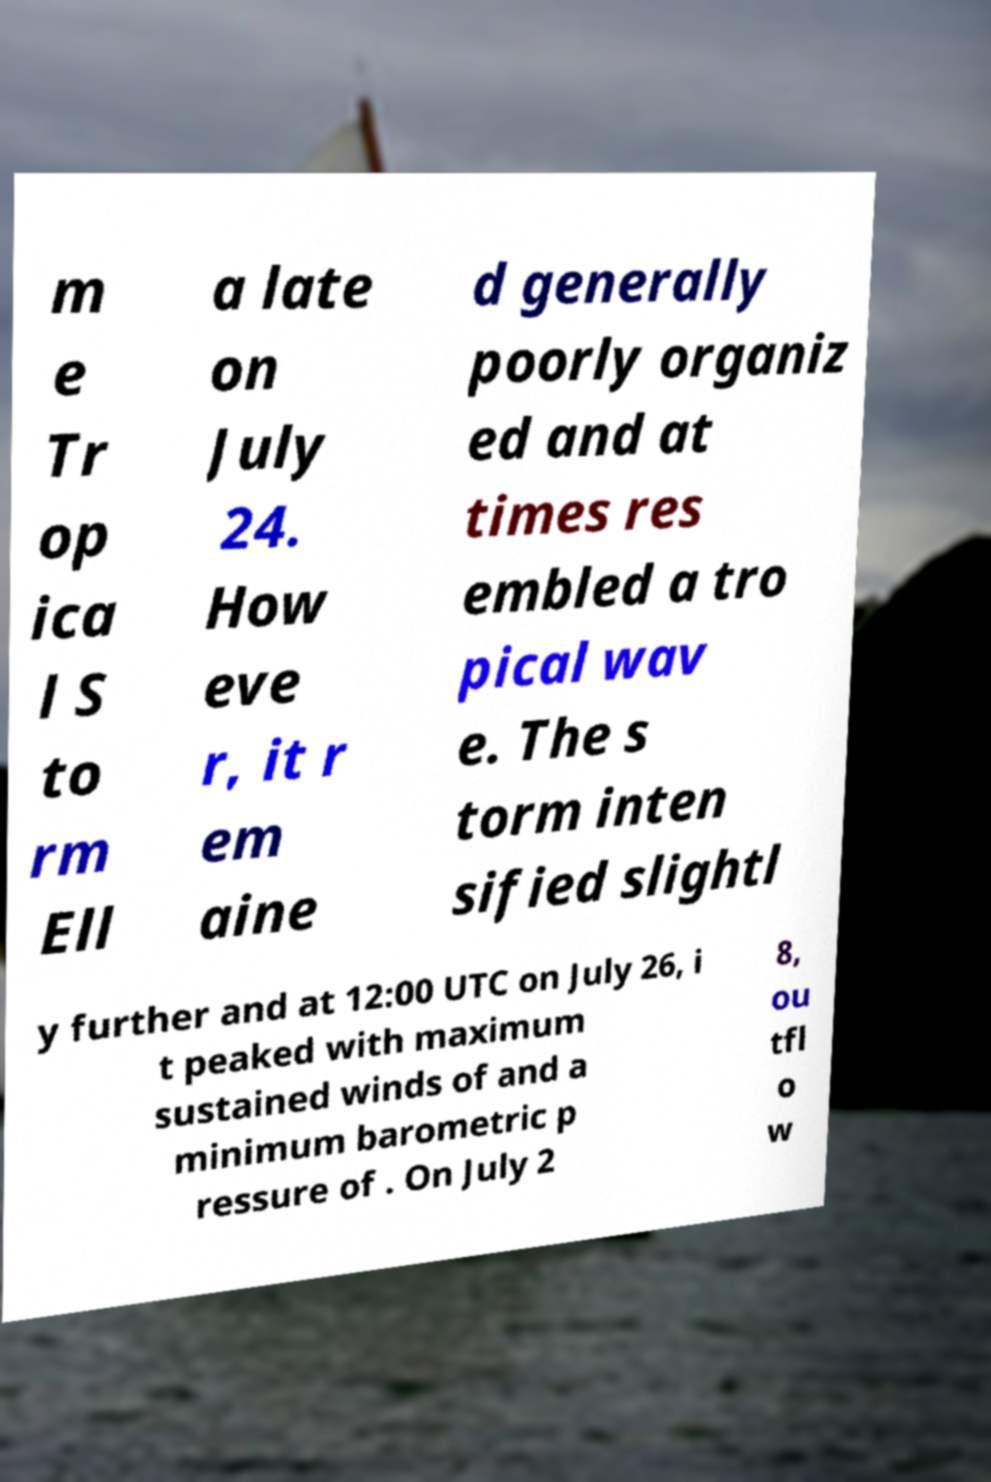Please identify and transcribe the text found in this image. m e Tr op ica l S to rm Ell a late on July 24. How eve r, it r em aine d generally poorly organiz ed and at times res embled a tro pical wav e. The s torm inten sified slightl y further and at 12:00 UTC on July 26, i t peaked with maximum sustained winds of and a minimum barometric p ressure of . On July 2 8, ou tfl o w 